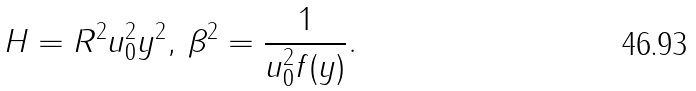<formula> <loc_0><loc_0><loc_500><loc_500>H = R ^ { 2 } u _ { 0 } ^ { 2 } y ^ { 2 } , \, \beta ^ { 2 } = \frac { 1 } { u _ { 0 } ^ { 2 } f ( y ) } .</formula> 